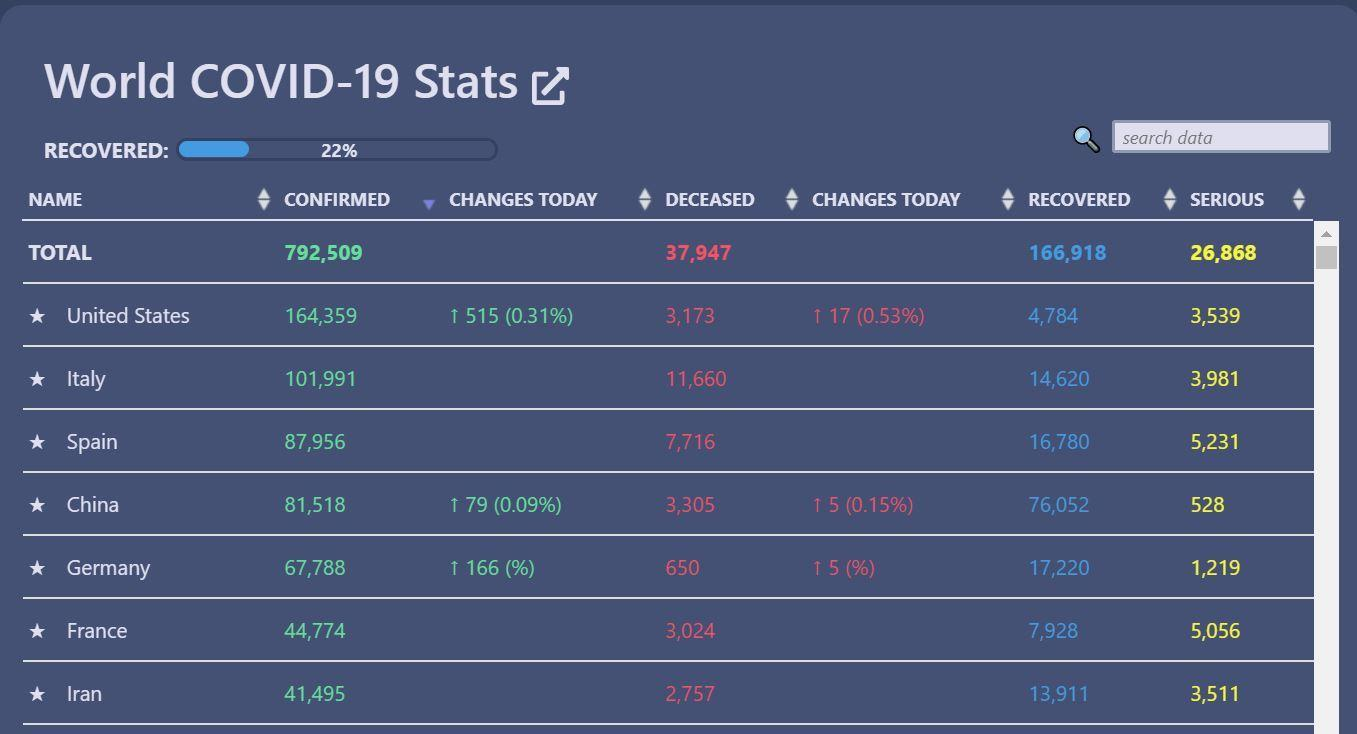Specify some key components in this picture. There have been a total of 31,400 cases of COVID-19 recovered in Italy and Spain combined. In total, there have been 86,269 confirmed cases of COVID-19 in France and Iran combined. There were a total of 5,759 serious cases in Spain and China combined. The total number of death cases in France and Iran combined is 5,781. 